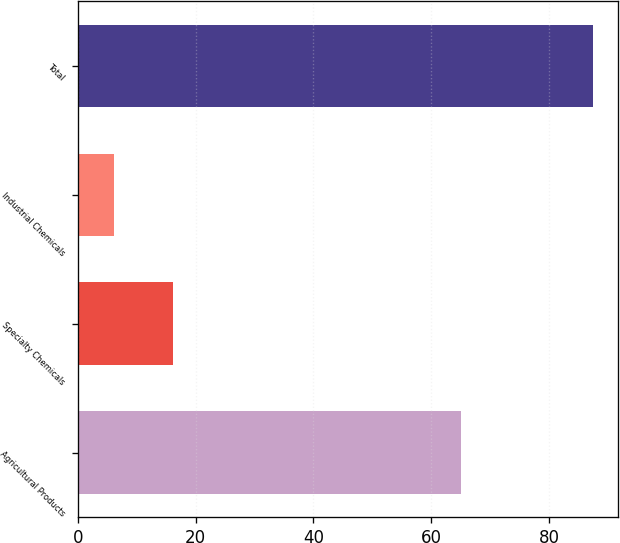<chart> <loc_0><loc_0><loc_500><loc_500><bar_chart><fcel>Agricultural Products<fcel>Specialty Chemicals<fcel>Industrial Chemicals<fcel>Total<nl><fcel>65.1<fcel>16.1<fcel>6.2<fcel>87.4<nl></chart> 